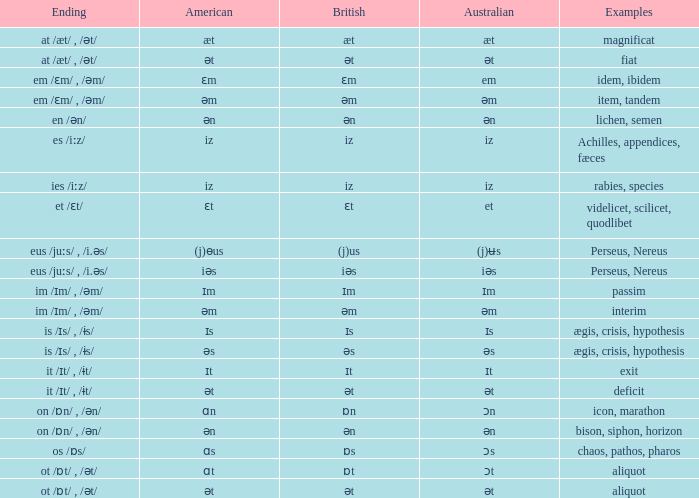Which Ending has British of iz, and Examples of achilles, appendices, fæces? Es /iːz/. 